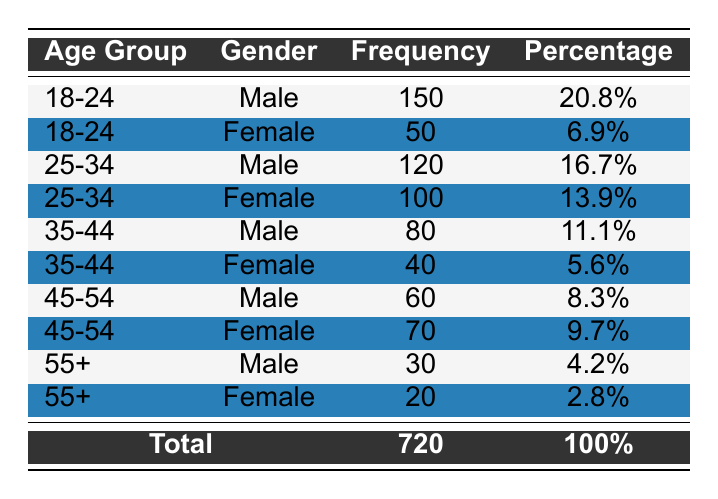What is the total frequency of male attendees? To find the total frequency of male attendees, I will add the frequencies for all entries where the gender is Male: 150 (18-24) + 80 (35-44) + 120 (25-34) + 60 (45-54) + 30 (55+) = 440.
Answer: 440 What is the frequency of female attendees in the age group 45-54? Looking at the table, the frequency of female attendees in the age group 45-54 is given explicitly as 70.
Answer: 70 Is the frequency of male attendees in the age group 55+ greater than that of female attendees in the same age group? The frequency of male attendees in the age group 55+ is 30, while the frequency of female attendees in the same age group is 20. Since 30 is greater than 20, the statement is true.
Answer: Yes What is the percentage of female attendees aged 35-44 relative to the total number of attendees? The frequency of female attendees aged 35-44 is 40, and the total number of attendees is 720. To calculate the percentage, I use (40 / 720) * 100, which equals approximately 5.6%.
Answer: 5.6% What is the combined frequency of attendees aged 25-34? I will add the frequencies for both genders in the 25-34 age group: 120 (Male) + 100 (Female) = 220.
Answer: 220 What age group has the highest percentage of attendees? To determine the age group with the highest percentage, I will compare the percentages: 20.8% for 18-24 Male, 16.7% for 25-34 Male, 13.9% for 25-34 Female, 11.1% for 35-44 Male, 5.6% for 35-44 Female, 8.3% for 45-54 Male, 9.7% for 45-54 Female, and 4.2% (55+ Male) and 2.8% (55+ Female). The highest is 20.8% from the 18-24 Male group.
Answer: 18-24 Male What is the difference in frequency between male and female attendees for the age group 35-44? The frequency of Male attendees in the age group 35-44 is 80, and for Female attendees, it is 40. The difference is 80 - 40 = 40.
Answer: 40 How many total attendees are aged below 35? The total frequency of attendees aged below 35 is the sum of attendees from age groups 18-24 (both genders) and 25-34 (both genders): 150 (18-24 Male) + 50 (18-24 Female) + 120 (25-34 Male) + 100 (25-34 Female) = 420.
Answer: 420 